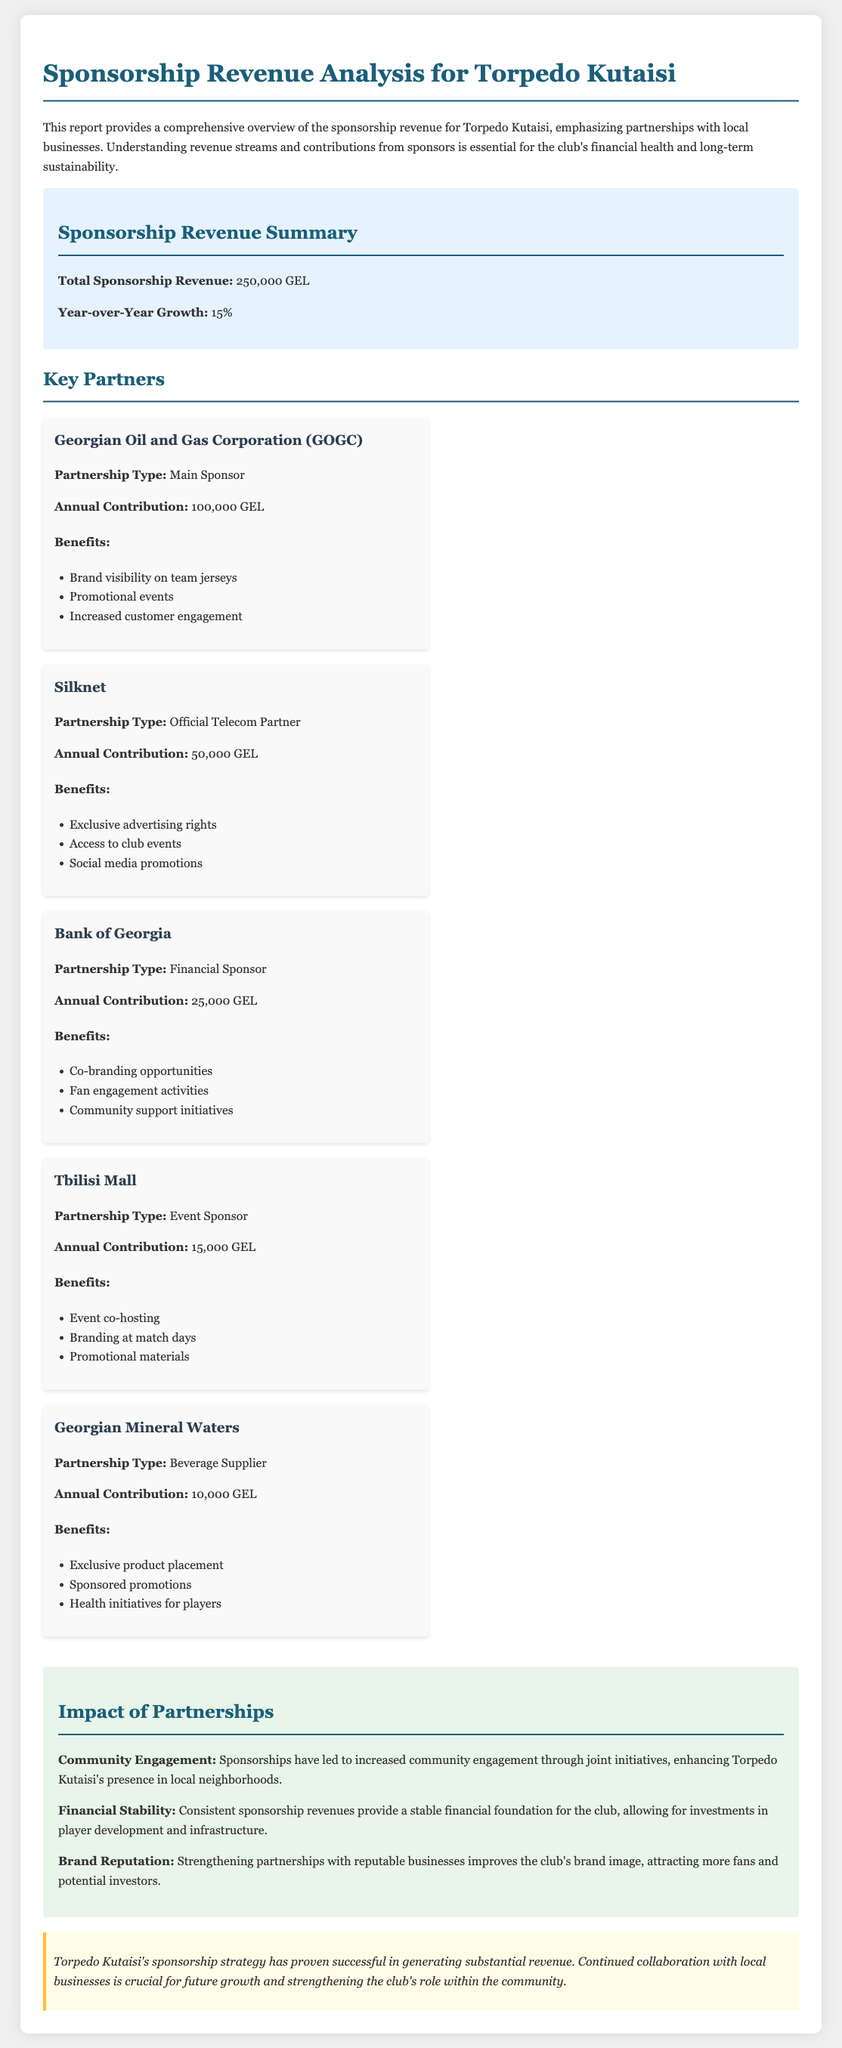What is the total sponsorship revenue? The total sponsorship revenue is explicitly mentioned in the summary section of the document.
Answer: 250,000 GEL What is the year-over-year growth percentage? The year-over-year growth percentage is provided in the summary section of the document.
Answer: 15% Who is the main sponsor of Torpedo Kutaisi? The document lists key partners and identifies the main sponsor among them.
Answer: Georgian Oil and Gas Corporation (GOGC) How much does Silknet contribute annually? The annual contribution from each partner is specified in the document under key partners.
Answer: 50,000 GEL What type of partnership does Tbilisi Mall have? The document categorizes the types of partnerships for each key partner.
Answer: Event Sponsor What are the benefits of the partnership with the Bank of Georgia? The document outlines benefits for key partners, including specific advantages from the Bank of Georgia.
Answer: Co-branding opportunities, Fan engagement activities, Community support initiatives What impact have the partnerships had on community engagement? The impact section discusses the effects of sponsorships on the community.
Answer: Increased community engagement through joint initiatives How does sponsorship revenue affect the club's financial stability? The document covers the implications of consistent sponsorship on financial stability.
Answer: Provides a stable financial foundation 